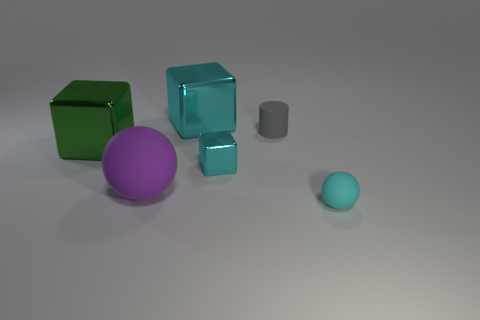Subtract all large metal blocks. How many blocks are left? 1 Subtract all brown balls. How many cyan blocks are left? 2 Add 4 gray cylinders. How many objects exist? 10 Subtract all cyan cubes. How many cubes are left? 1 Subtract all cylinders. How many objects are left? 5 Subtract all red cylinders. Subtract all yellow balls. How many cylinders are left? 1 Subtract all big cyan metal objects. Subtract all large cyan metal objects. How many objects are left? 4 Add 2 metallic cubes. How many metallic cubes are left? 5 Add 5 tiny things. How many tiny things exist? 8 Subtract 0 blue cylinders. How many objects are left? 6 